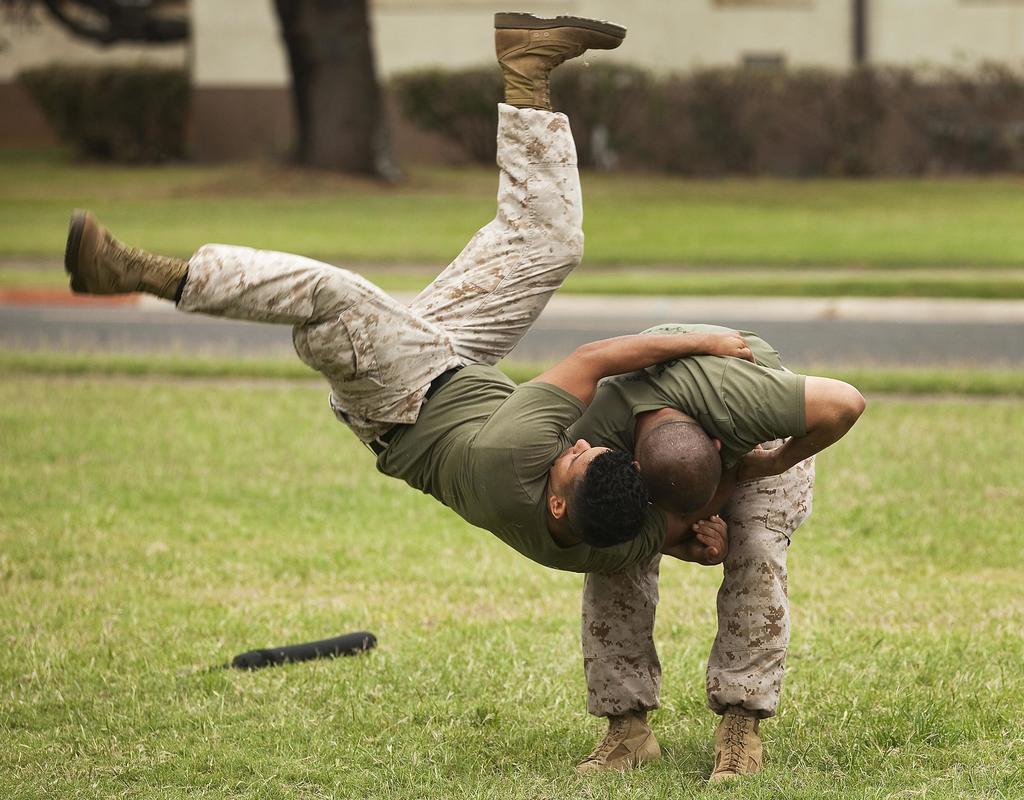Please provide a concise description of this image. In this picture I can see there are two people performing martial arts and there are wearing shoes, there is some grass on the floor, there are few plants, buildings in the backdrop. The backdrop of the image is blurred. 